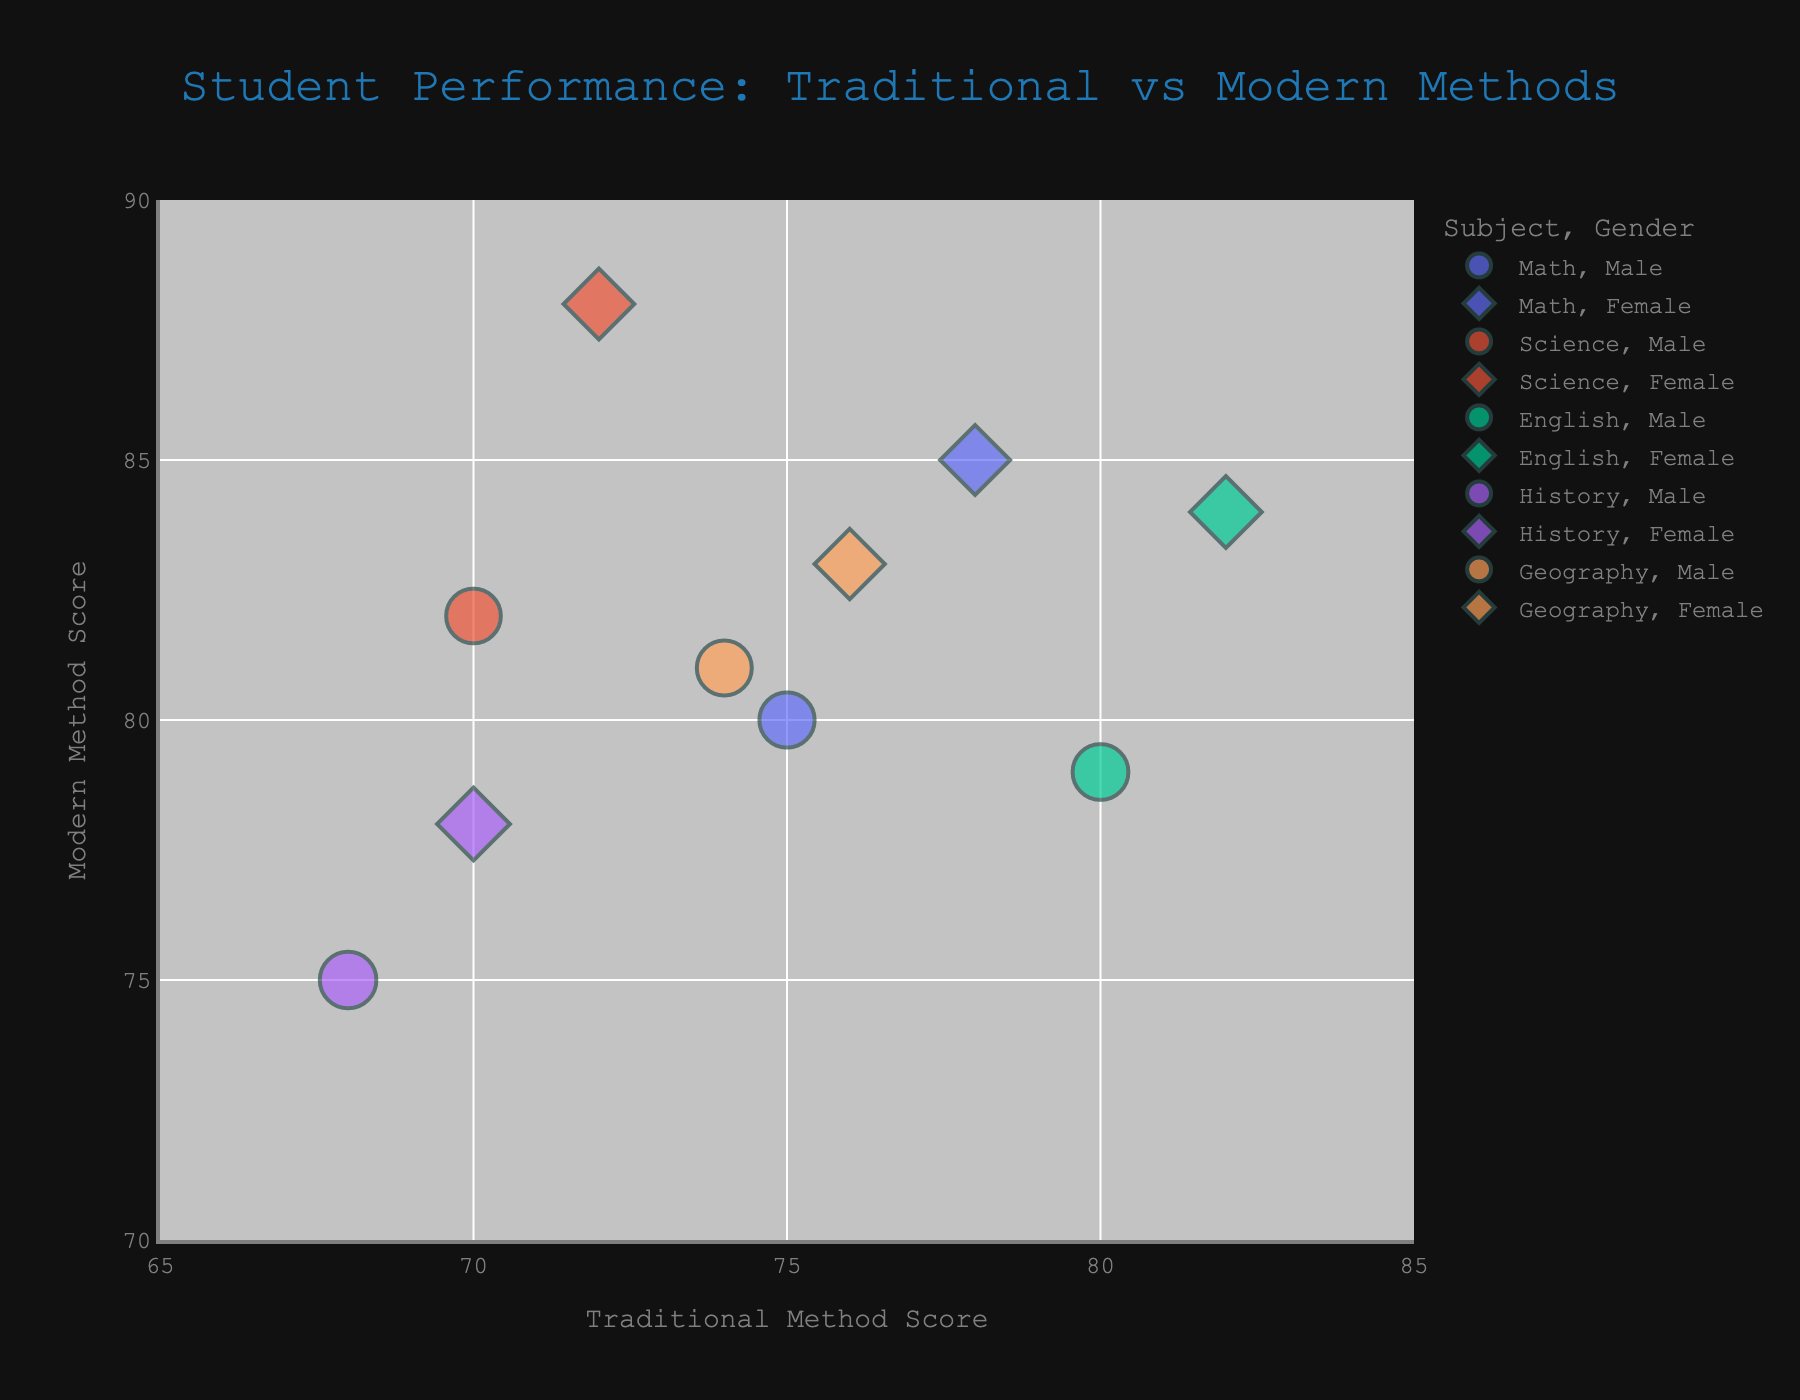What's the title of the figure? The title is usually located at the top of the figure, often indicating the main subject analyzed within the chart. Here, it is centered and formatted to be prominently visible.
Answer: Student Performance: Traditional vs Modern Methods Which subject and gender combination has the highest score in Modern Method? Locate the bubble with the highest point on the y-axis, which represents the Modern Method scores. Check the hover data to identify the subject and gender.
Answer: Science, Female How many data points are there in total? Count the number of bubbles on the chart. Each bubble represents a subject and gender combination.
Answer: 10 What is the range of the x-axis? The x-axis represents the Traditional Method scores. Look at the minimum and maximum values labeled along the axis.
Answer: 65 to 85 Which subject has the largest number of students for males? By looking at the size of the bubbles, find the largest bubble among male subjects, then check the hover data for the number of students.
Answer: History What is the difference in Modern Method scores between males and females in Geography? Locate the Geography bubbles for both male and female. Note their y-axis positions. Find the difference between the two scores: Female (83) and Male (81).
Answer: 2 What is the average Traditional Method score for Science across both genders? Locate the Science bubbles on the chart, note their x-axis positions for both genders, which are 70 (Male) and 72 (Female). Calculate their average: (70 + 72) / 2.
Answer: 71 Between Modern and Traditional Methods, which has shown better performance across all subjects? Compare the general position of the bubbles along the y-axis versus the x-axis. Since the y-axis scores (Modern Method) are generally higher than the x-axis scores (Traditional Method), Modern Method shows better performance.
Answer: Modern Method Are there any subjects where males perform better than females in Traditional Method? Look for any subjecting having higher x-axis values for male bubbles compared to female bubbles of the same subject. In "Math" and "English," males have lower scores in Traditional Method than females. So, there are none.
Answer: No In which subjects are female students close to or exceeding 85 in Modern Method scores? Locate the bubbles representing female students and note their y-axis scores. Identify the subject names for scores near or above 85.
Answer: Math and Science 